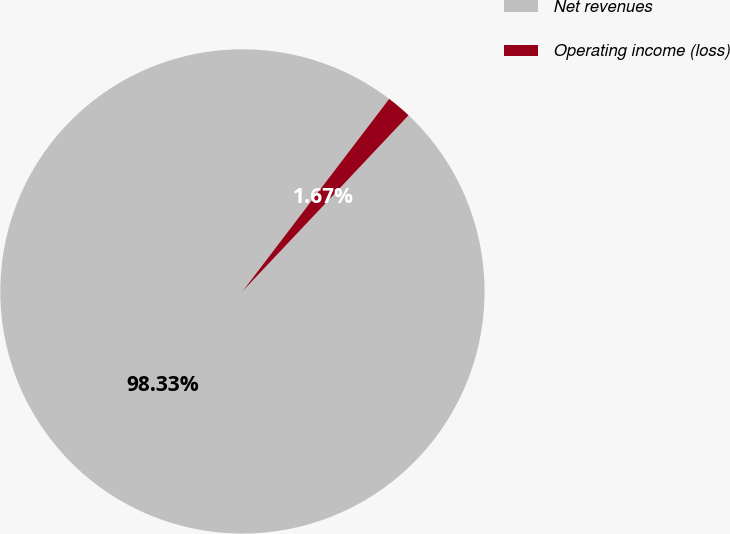Convert chart to OTSL. <chart><loc_0><loc_0><loc_500><loc_500><pie_chart><fcel>Net revenues<fcel>Operating income (loss)<nl><fcel>98.33%<fcel>1.67%<nl></chart> 